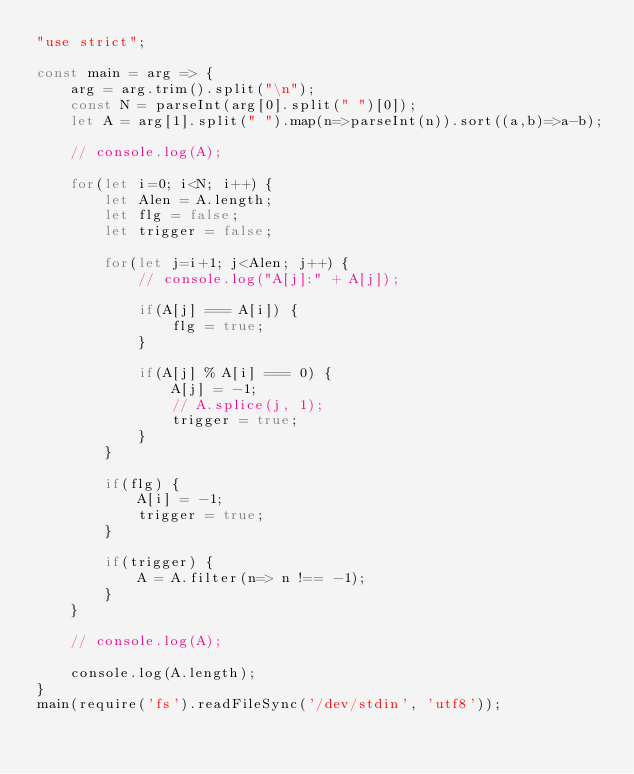<code> <loc_0><loc_0><loc_500><loc_500><_JavaScript_>"use strict";
    
const main = arg => {
    arg = arg.trim().split("\n");
    const N = parseInt(arg[0].split(" ")[0]);
    let A = arg[1].split(" ").map(n=>parseInt(n)).sort((a,b)=>a-b);
    
    // console.log(A);
    
    for(let i=0; i<N; i++) {
        let Alen = A.length;
        let flg = false;
        let trigger = false;
        
        for(let j=i+1; j<Alen; j++) {
            // console.log("A[j]:" + A[j]);
            
            if(A[j] === A[i]) {
                flg = true;
            }
            
            if(A[j] % A[i] === 0) {
                A[j] = -1;
                // A.splice(j, 1);
                trigger = true;
            }
        }
        
        if(flg) {
            A[i] = -1; 
            trigger = true;
        }
        
        if(trigger) {
            A = A.filter(n=> n !== -1);
        }
    }
    
    // console.log(A);

    console.log(A.length);
}
main(require('fs').readFileSync('/dev/stdin', 'utf8'));
</code> 